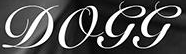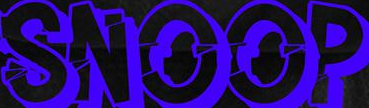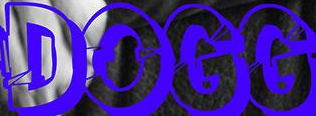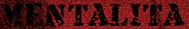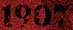Identify the words shown in these images in order, separated by a semicolon. DOGG; SNOOP; DOGG; MENTALITA; 1907 